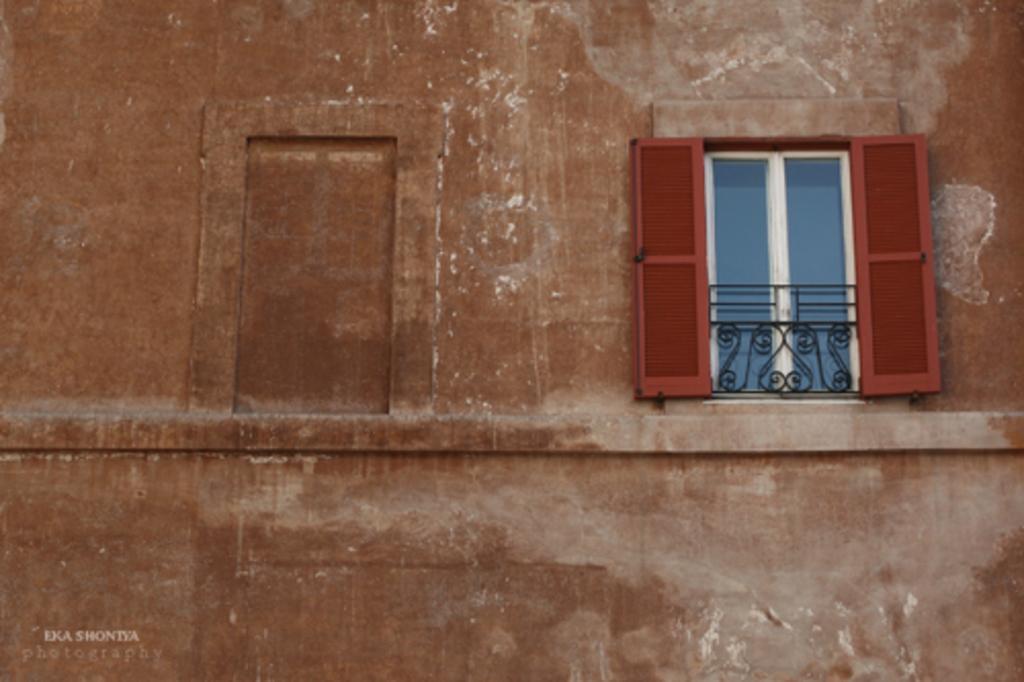How would you summarize this image in a sentence or two? There is a window at the right which has a door and a fence. There is a wall. 